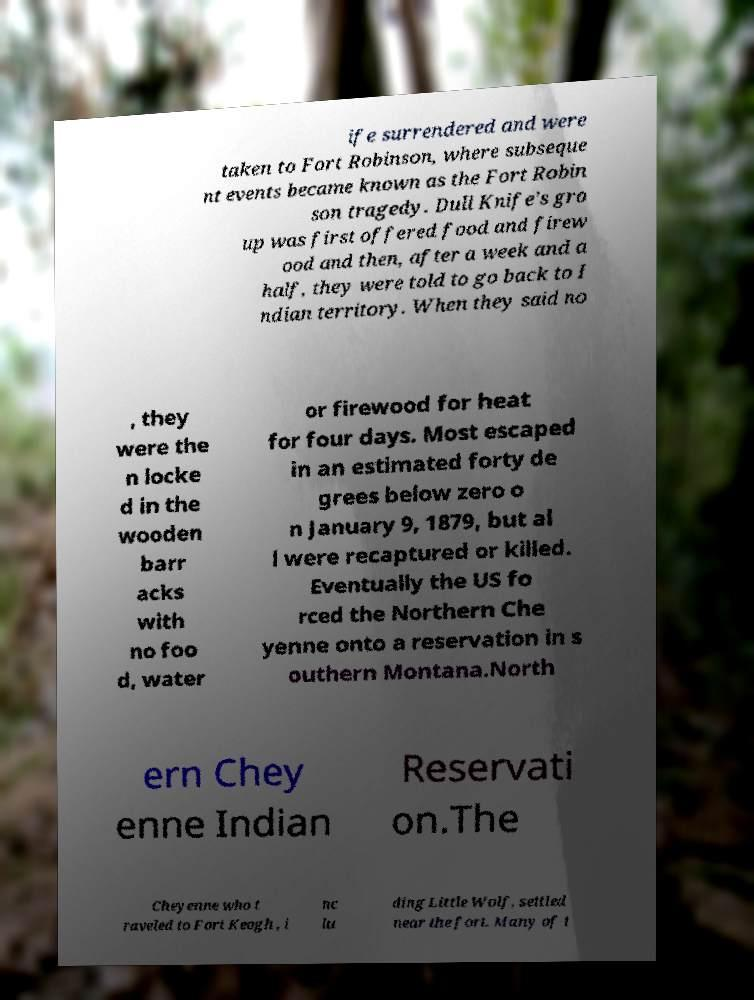Please read and relay the text visible in this image. What does it say? ife surrendered and were taken to Fort Robinson, where subseque nt events became known as the Fort Robin son tragedy. Dull Knife's gro up was first offered food and firew ood and then, after a week and a half, they were told to go back to I ndian territory. When they said no , they were the n locke d in the wooden barr acks with no foo d, water or firewood for heat for four days. Most escaped in an estimated forty de grees below zero o n January 9, 1879, but al l were recaptured or killed. Eventually the US fo rced the Northern Che yenne onto a reservation in s outhern Montana.North ern Chey enne Indian Reservati on.The Cheyenne who t raveled to Fort Keogh , i nc lu ding Little Wolf, settled near the fort. Many of t 